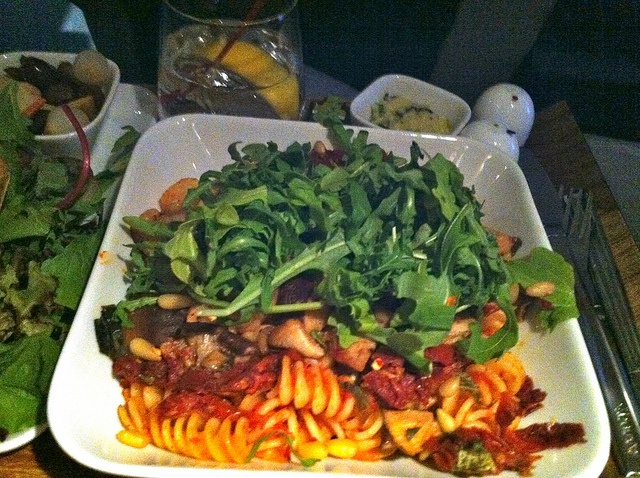Describe the objects in this image and their specific colors. I can see bowl in black, darkgreen, and darkgray tones, cup in black, darkgreen, gray, and olive tones, bowl in black, gray, darkgreen, and maroon tones, knife in black, gray, and darkgreen tones, and dining table in black, darkgreen, and gray tones in this image. 